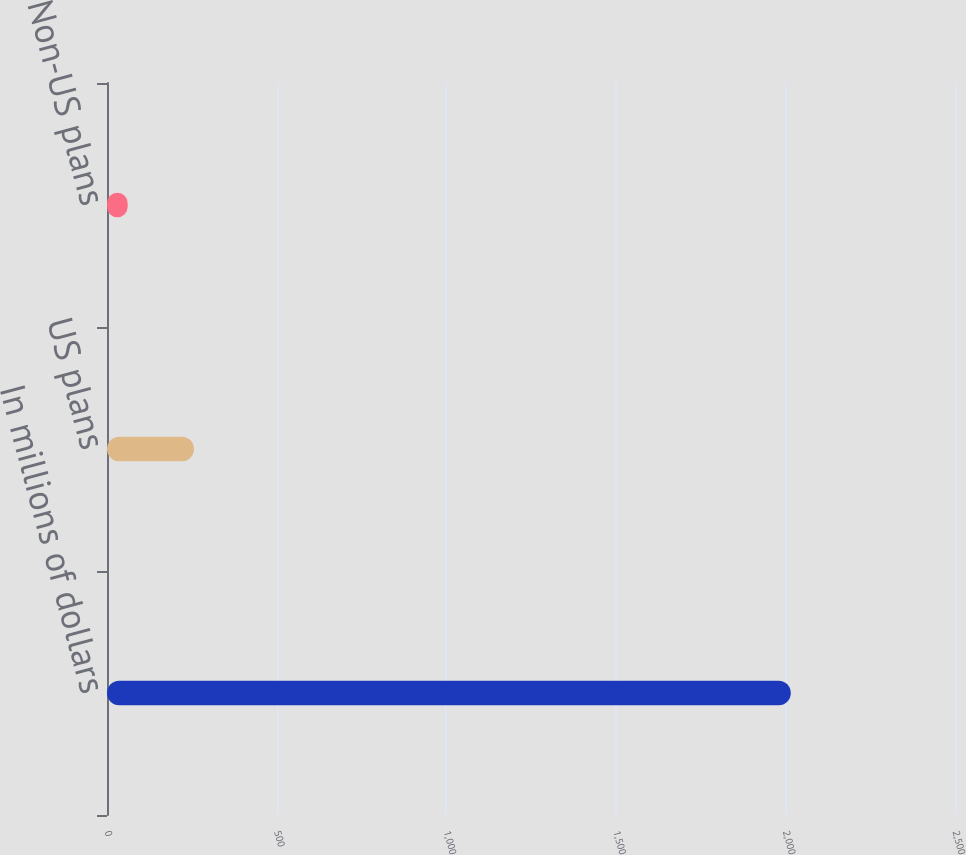<chart> <loc_0><loc_0><loc_500><loc_500><bar_chart><fcel>In millions of dollars<fcel>US plans<fcel>Non-US plans<nl><fcel>2016<fcel>256.5<fcel>61<nl></chart> 